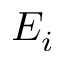<formula> <loc_0><loc_0><loc_500><loc_500>E _ { i }</formula> 